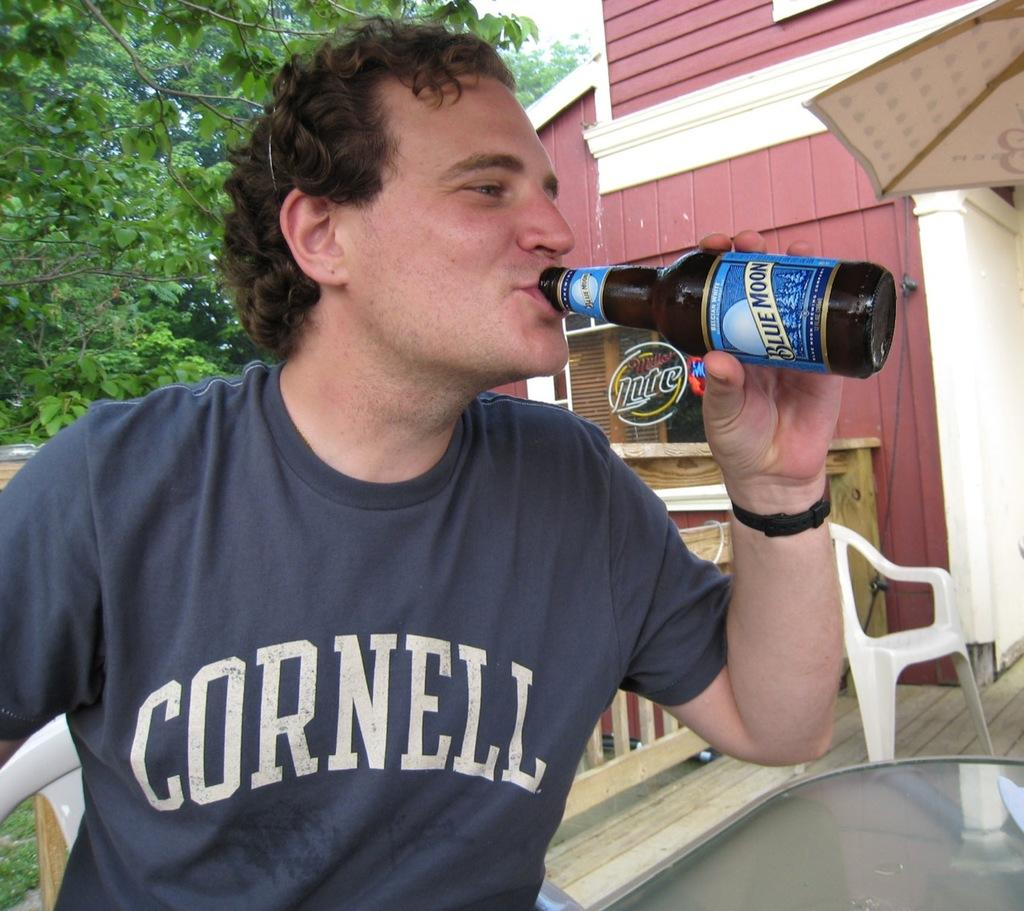Who is present in the image? There is a man in the picture. What is the man doing in the image? The man is sitting on a chair and drinking from a bottle. What can be seen in the background of the picture? There is a tree and a building in the background of the picture. What type of payment is the man receiving from the crook in the image? There is no crook or payment present in the image; it only features a man sitting on a chair and drinking from a bottle. 